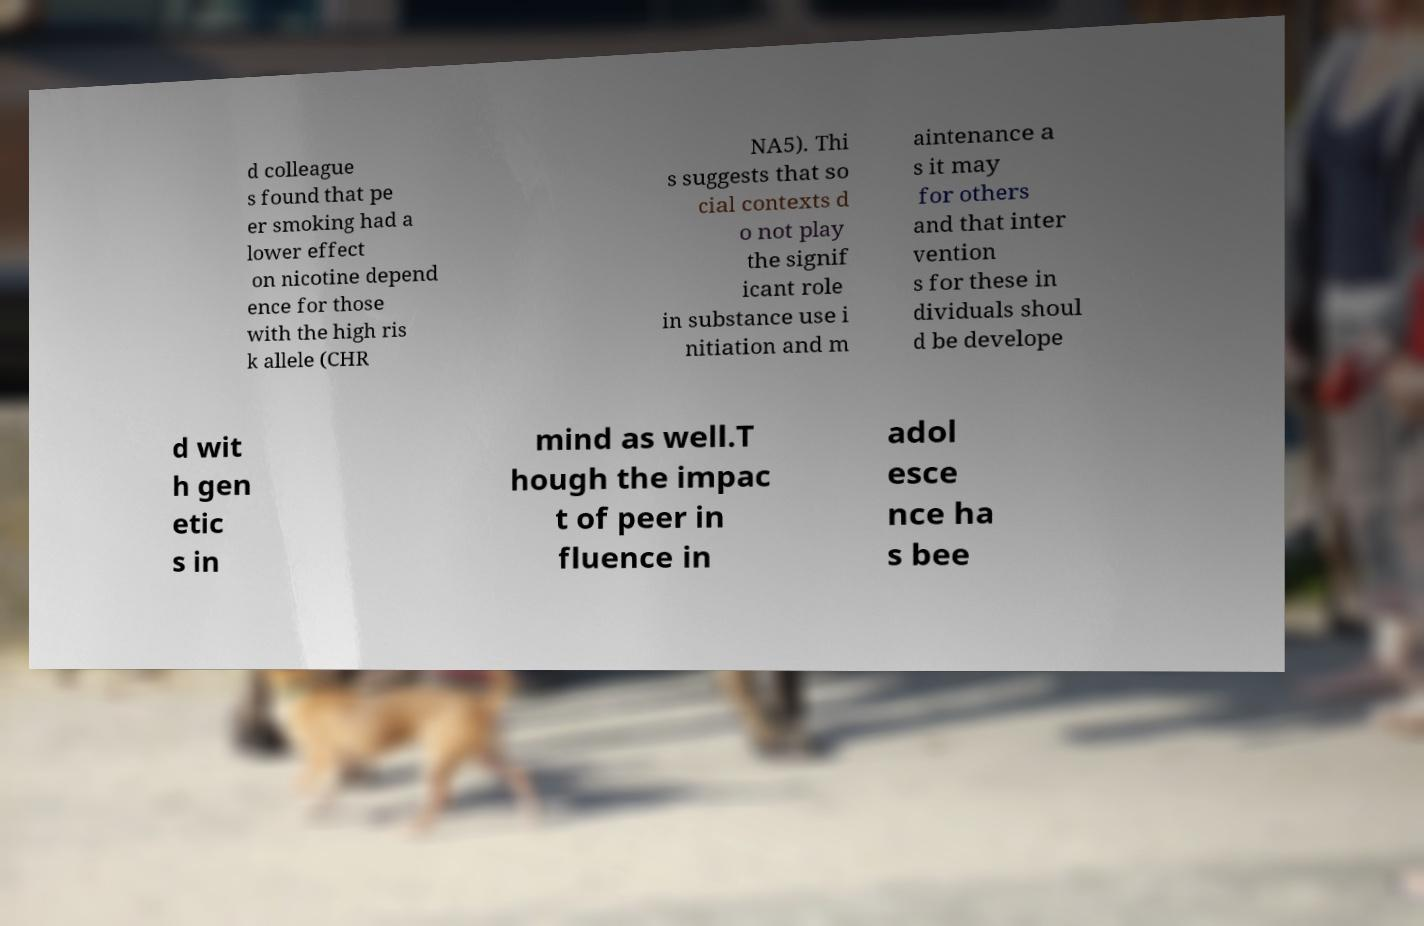For documentation purposes, I need the text within this image transcribed. Could you provide that? d colleague s found that pe er smoking had a lower effect on nicotine depend ence for those with the high ris k allele (CHR NA5). Thi s suggests that so cial contexts d o not play the signif icant role in substance use i nitiation and m aintenance a s it may for others and that inter vention s for these in dividuals shoul d be develope d wit h gen etic s in mind as well.T hough the impac t of peer in fluence in adol esce nce ha s bee 